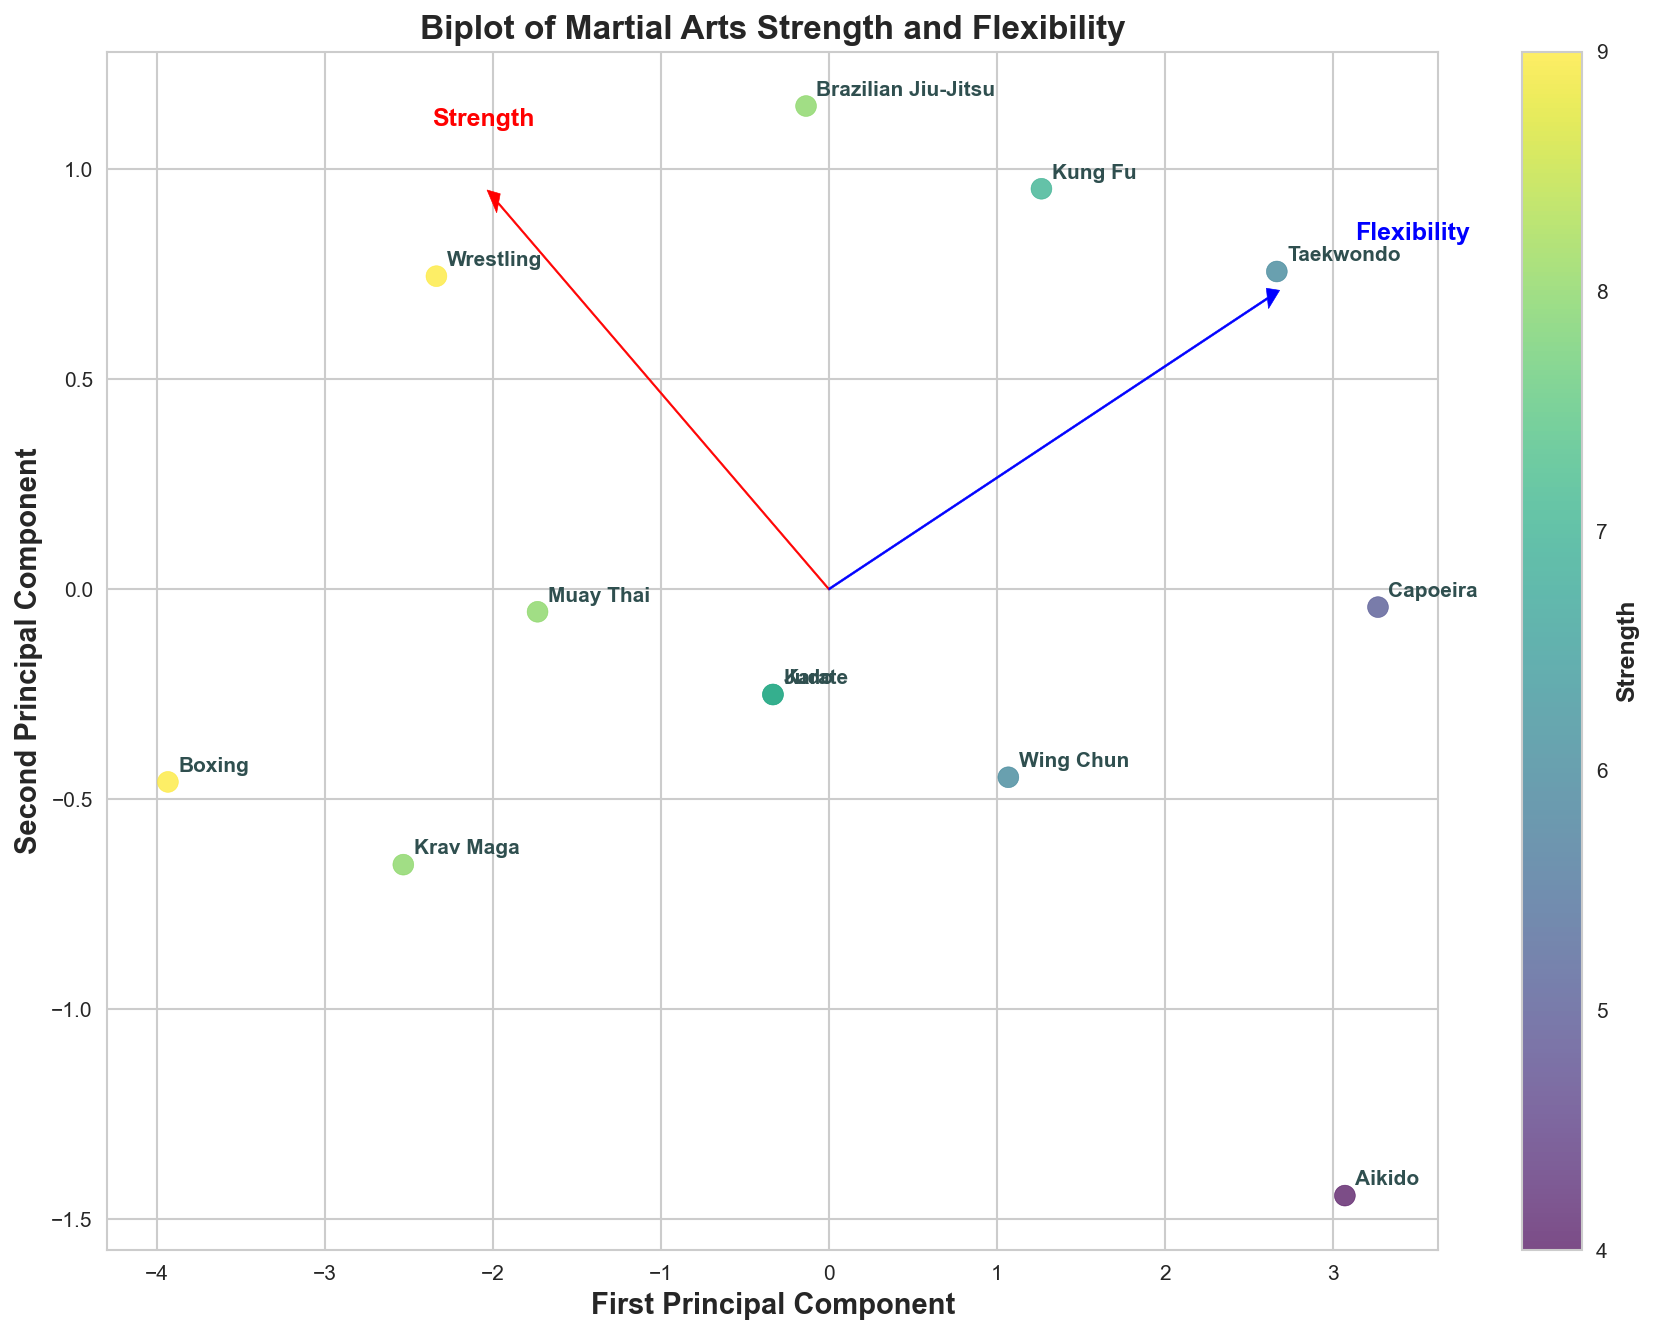what is the title of the figure? The title is displayed at the top of the figure and indicates what the figure is about. It says "Biplot of Martial Arts Strength and Flexibility".
Answer: Biplot of Martial Arts Strength and Flexibility How many data points are displayed in the plot? Each point corresponds to a martial art style and is represented by a label. By counting the labels, we identify 12 data points.
Answer: 12 Which martial art has the highest flexibility? Flexibility values are indicated by the blue axis direction and examining the plot reveals that Taekwondo has the highest flexibility.
Answer: Taekwondo Which martial art has the lowest strength? Strength values are indicated by the red axis direction, and Aikido is located closest to the origin along this axis, representing the lowest strength.
Answer: Aikido Which martial art lies closest to the first principal component axis? The first principal component axis is the horizontal axis, and Boxing, Wrestling, and Karate appear closest to it. Each has a strong strength attribute contributing to this placement.
Answer: Boxing, Wrestling, and Karate Compare the average strength between Karate and Judo. Identify Karate and Judo on the plot and average their strength values (7 for both). The average = (7+7)/2 = 7.
Answer: 7 Which martial art lies furthest from the origin? The distance from the origin can be gauged visually by checking the points from the equilibrium center, and Taekwondo appears to be the furthest due to its high flexibility attribute.
Answer: Taekwondo Are there any martial arts exhibiting both high flexibility and high strength? Checking the plot where both the red (strength) and blue (flexibility) arrows point, Brazilian Jiu-Jitsu, Kung Fu, and Aikido exhibit high values in both attributes.
Answer: Brazilian Jiu-Jitsu, Kung Fu, and Aikido Compare the flexibility of Muay Thai and Capoeira. Which one is higher? Locate Muay Thai and Capoeira on the plot along the blue axis direction. Capoeira is situated higher on flexibility.
Answer: Capoeira Which martial art balances strength and flexibility most equally? Locate points that are plotted equidistantly along both the red (strength) and blue (flexibility) vectors. Judo is one such martial art, showing balanced values in both dimensions.
Answer: Judo 